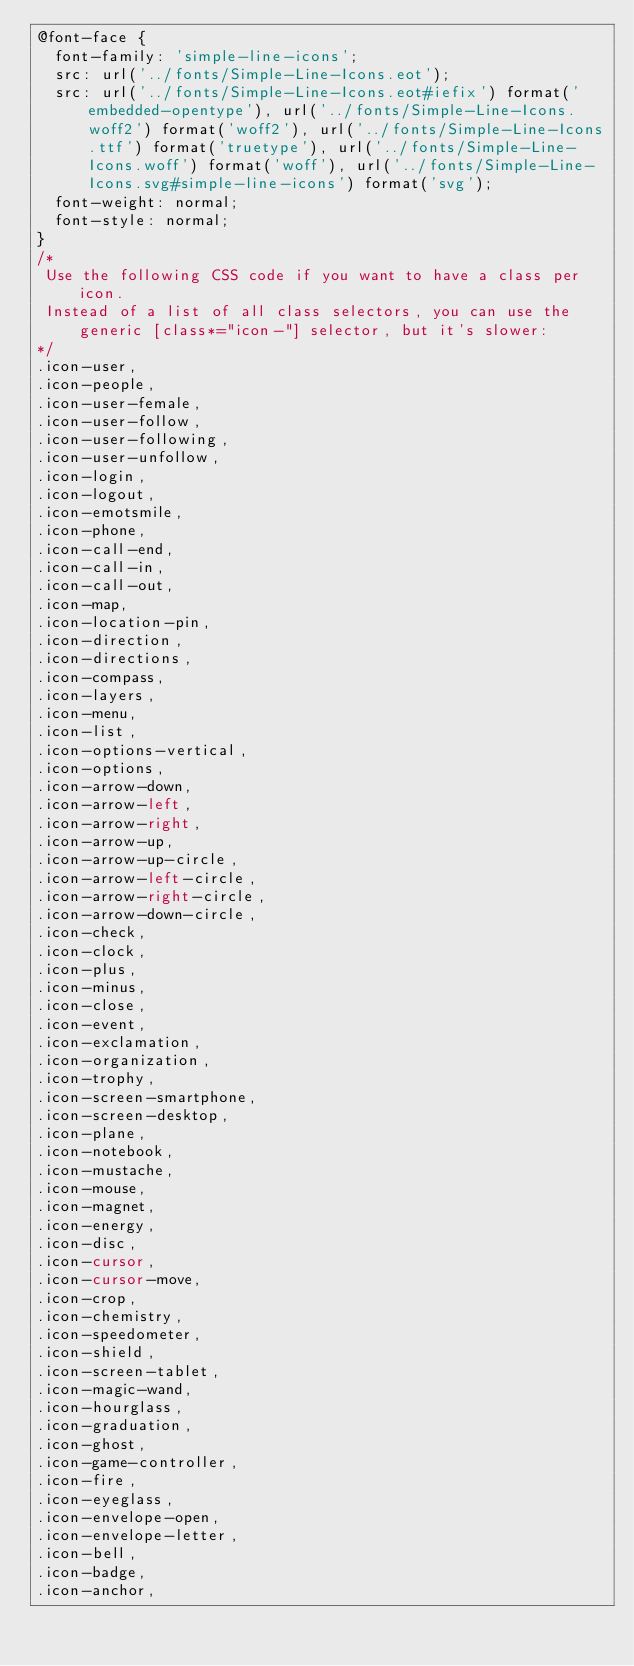<code> <loc_0><loc_0><loc_500><loc_500><_CSS_>@font-face {
  font-family: 'simple-line-icons';
  src: url('../fonts/Simple-Line-Icons.eot');
  src: url('../fonts/Simple-Line-Icons.eot#iefix') format('embedded-opentype'), url('../fonts/Simple-Line-Icons.woff2') format('woff2'), url('../fonts/Simple-Line-Icons.ttf') format('truetype'), url('../fonts/Simple-Line-Icons.woff') format('woff'), url('../fonts/Simple-Line-Icons.svg#simple-line-icons') format('svg');
  font-weight: normal;
  font-style: normal;
}
/*
 Use the following CSS code if you want to have a class per icon.
 Instead of a list of all class selectors, you can use the generic [class*="icon-"] selector, but it's slower:
*/
.icon-user,
.icon-people,
.icon-user-female,
.icon-user-follow,
.icon-user-following,
.icon-user-unfollow,
.icon-login,
.icon-logout,
.icon-emotsmile,
.icon-phone,
.icon-call-end,
.icon-call-in,
.icon-call-out,
.icon-map,
.icon-location-pin,
.icon-direction,
.icon-directions,
.icon-compass,
.icon-layers,
.icon-menu,
.icon-list,
.icon-options-vertical,
.icon-options,
.icon-arrow-down,
.icon-arrow-left,
.icon-arrow-right,
.icon-arrow-up,
.icon-arrow-up-circle,
.icon-arrow-left-circle,
.icon-arrow-right-circle,
.icon-arrow-down-circle,
.icon-check,
.icon-clock,
.icon-plus,
.icon-minus,
.icon-close,
.icon-event,
.icon-exclamation,
.icon-organization,
.icon-trophy,
.icon-screen-smartphone,
.icon-screen-desktop,
.icon-plane,
.icon-notebook,
.icon-mustache,
.icon-mouse,
.icon-magnet,
.icon-energy,
.icon-disc,
.icon-cursor,
.icon-cursor-move,
.icon-crop,
.icon-chemistry,
.icon-speedometer,
.icon-shield,
.icon-screen-tablet,
.icon-magic-wand,
.icon-hourglass,
.icon-graduation,
.icon-ghost,
.icon-game-controller,
.icon-fire,
.icon-eyeglass,
.icon-envelope-open,
.icon-envelope-letter,
.icon-bell,
.icon-badge,
.icon-anchor,</code> 